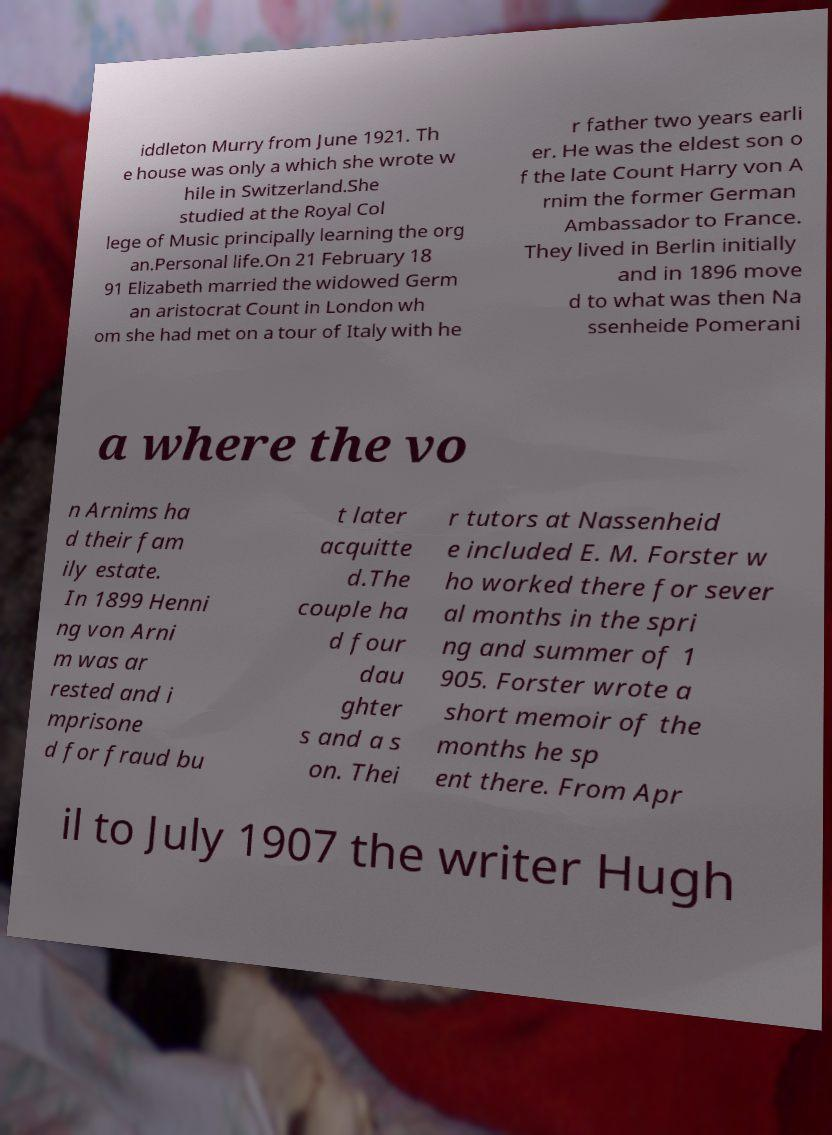Could you extract and type out the text from this image? iddleton Murry from June 1921. Th e house was only a which she wrote w hile in Switzerland.She studied at the Royal Col lege of Music principally learning the org an.Personal life.On 21 February 18 91 Elizabeth married the widowed Germ an aristocrat Count in London wh om she had met on a tour of Italy with he r father two years earli er. He was the eldest son o f the late Count Harry von A rnim the former German Ambassador to France. They lived in Berlin initially and in 1896 move d to what was then Na ssenheide Pomerani a where the vo n Arnims ha d their fam ily estate. In 1899 Henni ng von Arni m was ar rested and i mprisone d for fraud bu t later acquitte d.The couple ha d four dau ghter s and a s on. Thei r tutors at Nassenheid e included E. M. Forster w ho worked there for sever al months in the spri ng and summer of 1 905. Forster wrote a short memoir of the months he sp ent there. From Apr il to July 1907 the writer Hugh 